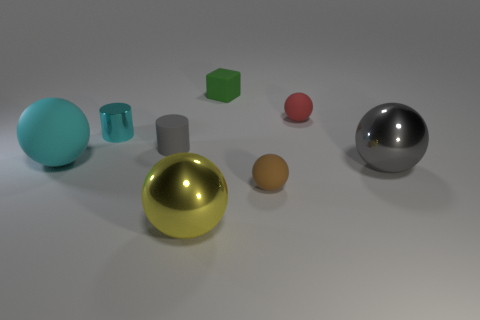What number of other things are there of the same material as the tiny gray thing
Keep it short and to the point. 4. Is the number of red matte balls on the right side of the big matte sphere greater than the number of gray metal spheres left of the green rubber cube?
Your answer should be compact. Yes. Are any small green things visible?
Your answer should be very brief. Yes. There is a large object that is the same color as the tiny metal object; what material is it?
Provide a short and direct response. Rubber. What number of objects are either big things or cyan matte things?
Offer a very short reply. 3. Are there any tiny matte objects that have the same color as the rubber block?
Make the answer very short. No. What number of rubber blocks are in front of the large metallic ball in front of the brown matte thing?
Offer a terse response. 0. Are there more tiny matte blocks than blue blocks?
Offer a terse response. Yes. Does the small green object have the same material as the tiny cyan cylinder?
Your answer should be compact. No. Is the number of large cyan rubber objects right of the cyan matte ball the same as the number of gray rubber things?
Ensure brevity in your answer.  No. 